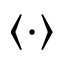<formula> <loc_0><loc_0><loc_500><loc_500>\langle \cdot \rangle</formula> 